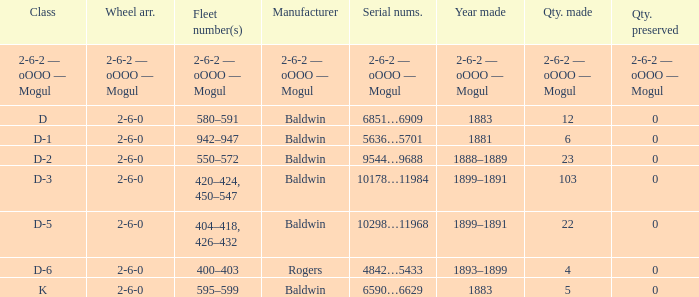What is the quantity made when the class is d-2? 23.0. 